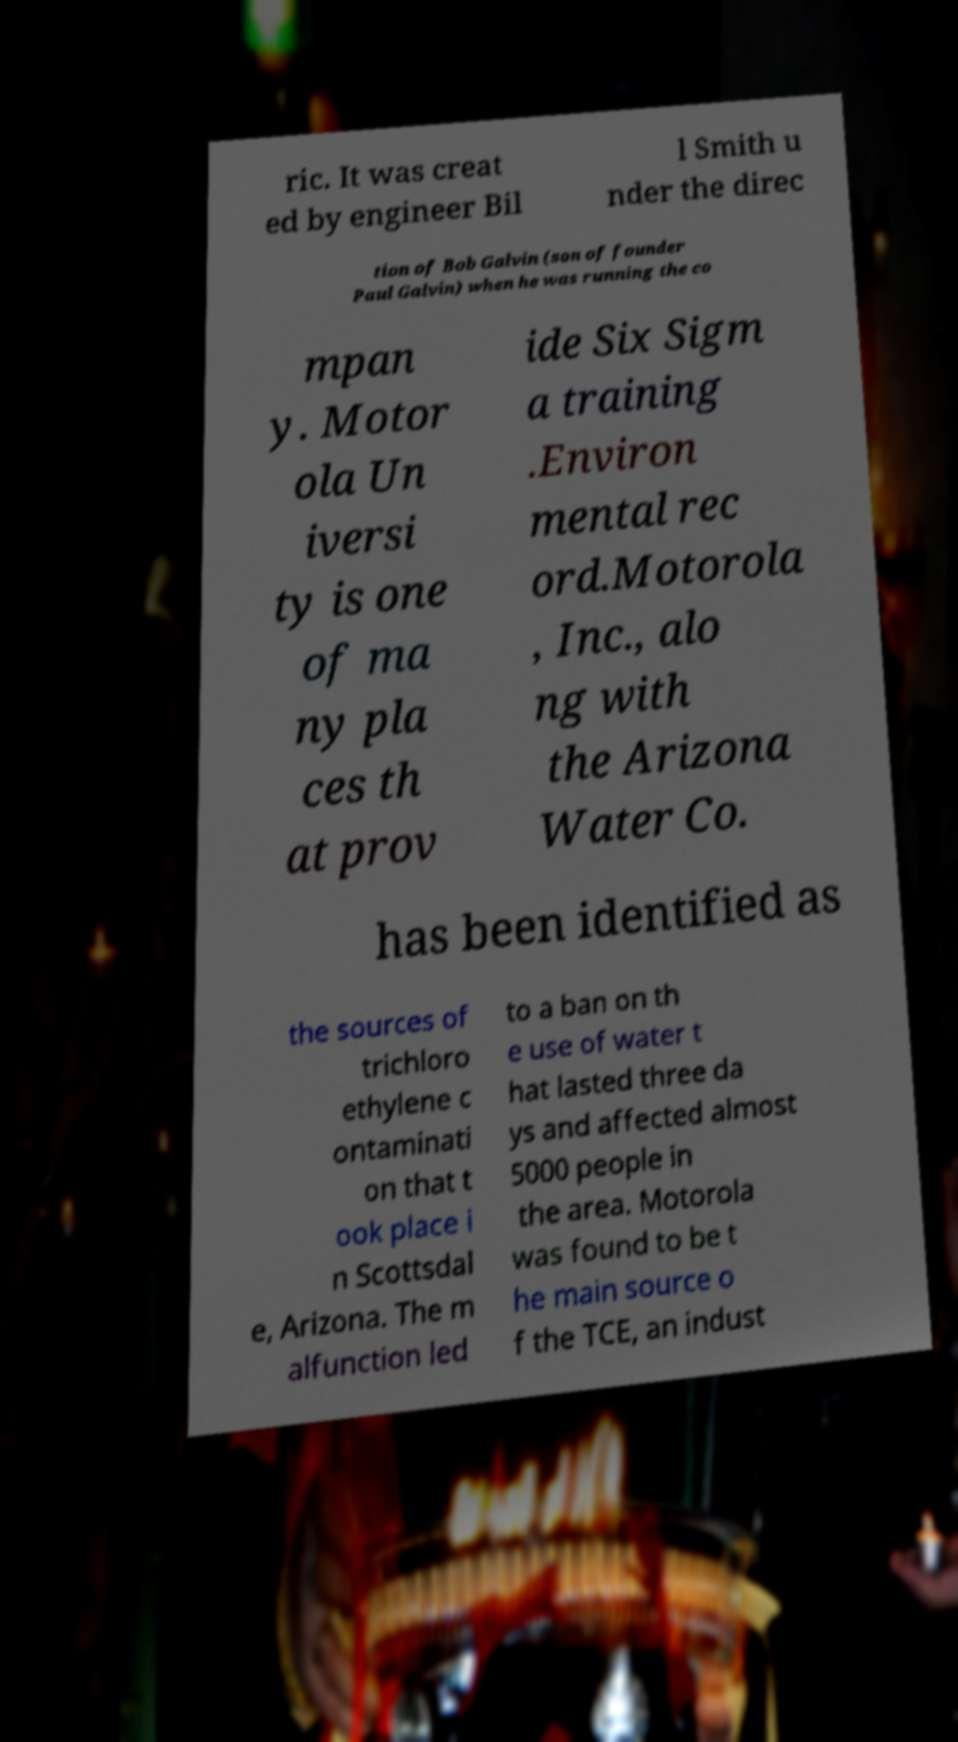Can you read and provide the text displayed in the image?This photo seems to have some interesting text. Can you extract and type it out for me? ric. It was creat ed by engineer Bil l Smith u nder the direc tion of Bob Galvin (son of founder Paul Galvin) when he was running the co mpan y. Motor ola Un iversi ty is one of ma ny pla ces th at prov ide Six Sigm a training .Environ mental rec ord.Motorola , Inc., alo ng with the Arizona Water Co. has been identified as the sources of trichloro ethylene c ontaminati on that t ook place i n Scottsdal e, Arizona. The m alfunction led to a ban on th e use of water t hat lasted three da ys and affected almost 5000 people in the area. Motorola was found to be t he main source o f the TCE, an indust 